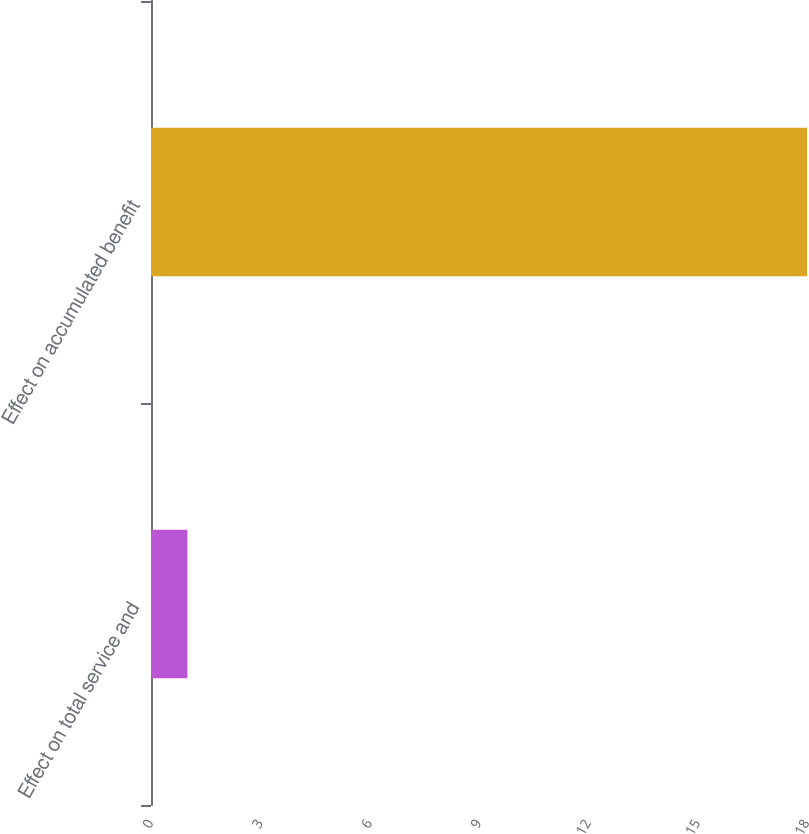Convert chart to OTSL. <chart><loc_0><loc_0><loc_500><loc_500><bar_chart><fcel>Effect on total service and<fcel>Effect on accumulated benefit<nl><fcel>1<fcel>18<nl></chart> 